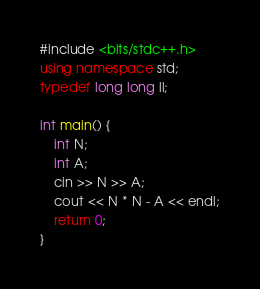<code> <loc_0><loc_0><loc_500><loc_500><_C++_>#include <bits/stdc++.h>
using namespace std;
typedef long long ll;

int main() {
    int N;
    int A;
    cin >> N >> A;
    cout << N * N - A << endl;
    return 0;
}</code> 